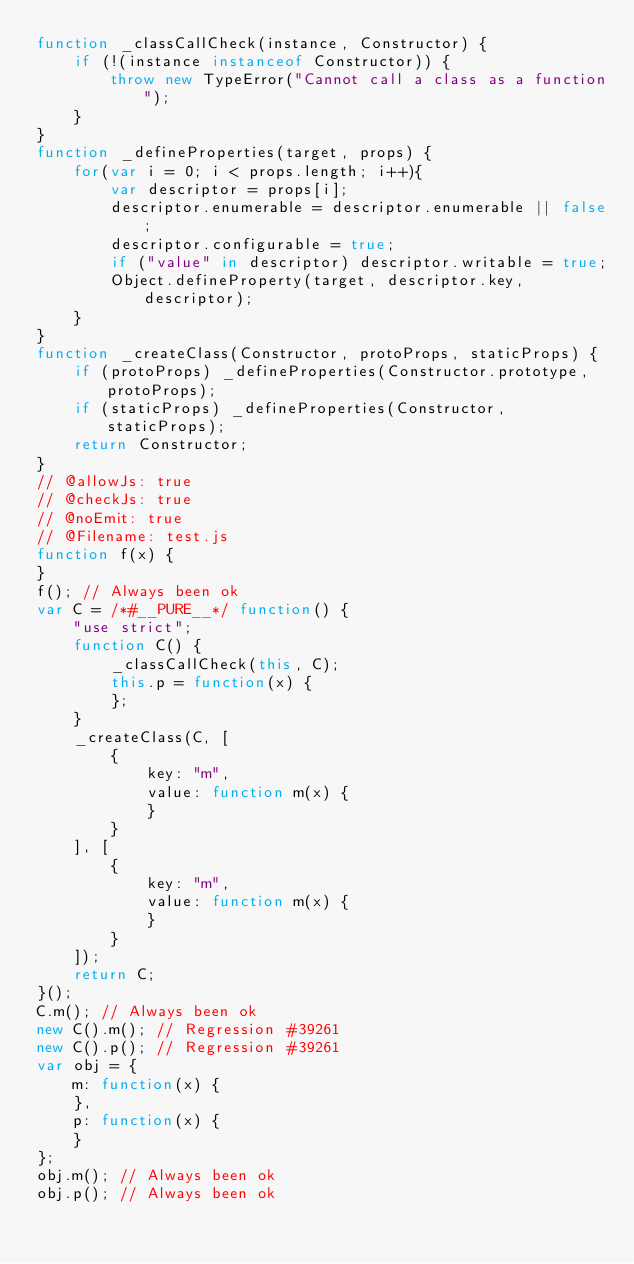Convert code to text. <code><loc_0><loc_0><loc_500><loc_500><_JavaScript_>function _classCallCheck(instance, Constructor) {
    if (!(instance instanceof Constructor)) {
        throw new TypeError("Cannot call a class as a function");
    }
}
function _defineProperties(target, props) {
    for(var i = 0; i < props.length; i++){
        var descriptor = props[i];
        descriptor.enumerable = descriptor.enumerable || false;
        descriptor.configurable = true;
        if ("value" in descriptor) descriptor.writable = true;
        Object.defineProperty(target, descriptor.key, descriptor);
    }
}
function _createClass(Constructor, protoProps, staticProps) {
    if (protoProps) _defineProperties(Constructor.prototype, protoProps);
    if (staticProps) _defineProperties(Constructor, staticProps);
    return Constructor;
}
// @allowJs: true
// @checkJs: true
// @noEmit: true
// @Filename: test.js
function f(x) {
}
f(); // Always been ok
var C = /*#__PURE__*/ function() {
    "use strict";
    function C() {
        _classCallCheck(this, C);
        this.p = function(x) {
        };
    }
    _createClass(C, [
        {
            key: "m",
            value: function m(x) {
            }
        }
    ], [
        {
            key: "m",
            value: function m(x) {
            }
        }
    ]);
    return C;
}();
C.m(); // Always been ok
new C().m(); // Regression #39261
new C().p(); // Regression #39261
var obj = {
    m: function(x) {
    },
    p: function(x) {
    }
};
obj.m(); // Always been ok
obj.p(); // Always been ok
</code> 